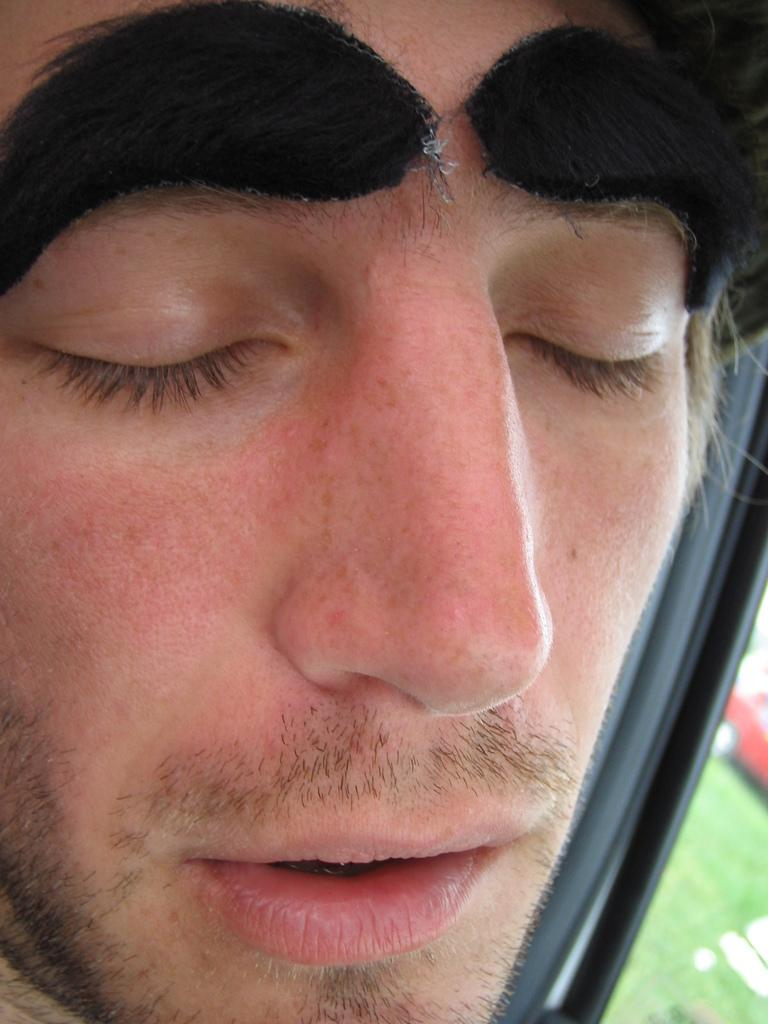What is the main subject of the image? There is a man's face in the image. What type of natural environment can be seen in the image? There is grass visible in the image. What type of waves can be seen crashing on the shore in the image? There are no waves present in the image. 